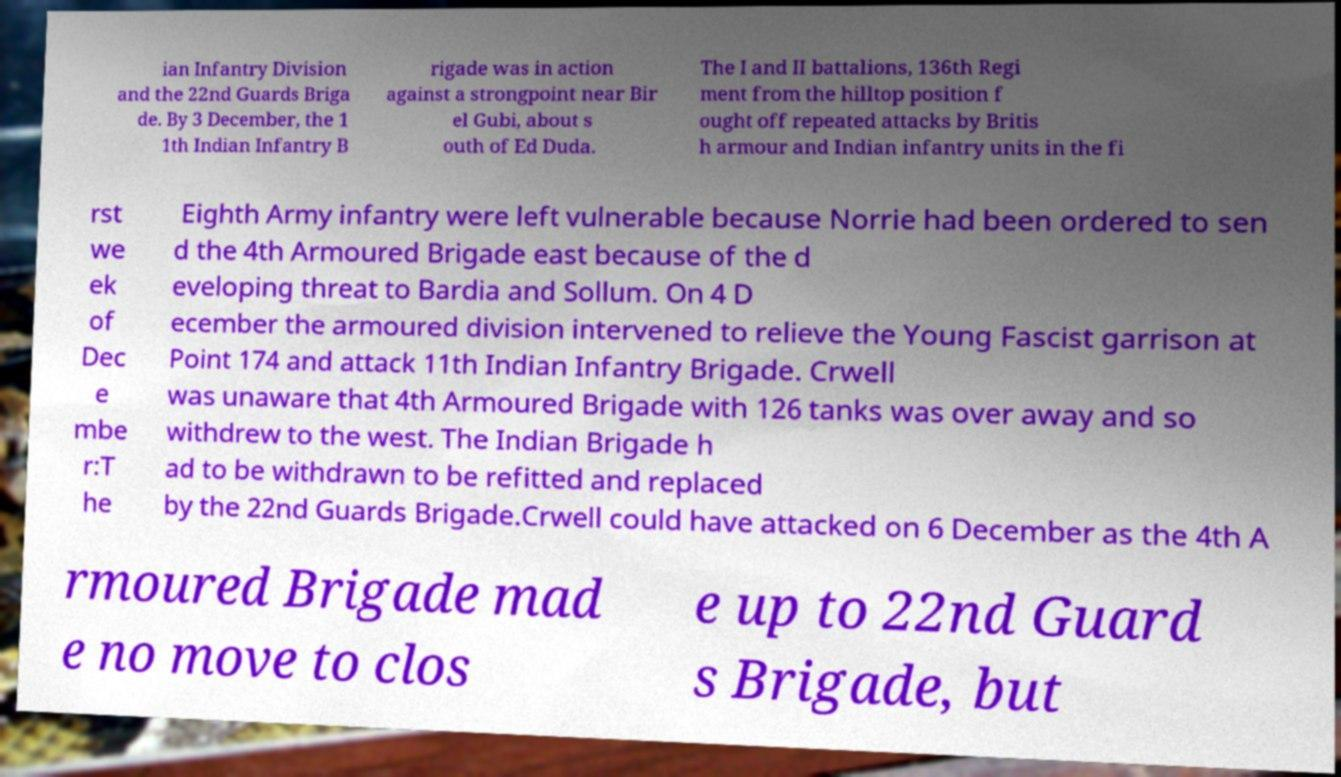Can you accurately transcribe the text from the provided image for me? ian Infantry Division and the 22nd Guards Briga de. By 3 December, the 1 1th Indian Infantry B rigade was in action against a strongpoint near Bir el Gubi, about s outh of Ed Duda. The I and II battalions, 136th Regi ment from the hilltop position f ought off repeated attacks by Britis h armour and Indian infantry units in the fi rst we ek of Dec e mbe r:T he Eighth Army infantry were left vulnerable because Norrie had been ordered to sen d the 4th Armoured Brigade east because of the d eveloping threat to Bardia and Sollum. On 4 D ecember the armoured division intervened to relieve the Young Fascist garrison at Point 174 and attack 11th Indian Infantry Brigade. Crwell was unaware that 4th Armoured Brigade with 126 tanks was over away and so withdrew to the west. The Indian Brigade h ad to be withdrawn to be refitted and replaced by the 22nd Guards Brigade.Crwell could have attacked on 6 December as the 4th A rmoured Brigade mad e no move to clos e up to 22nd Guard s Brigade, but 